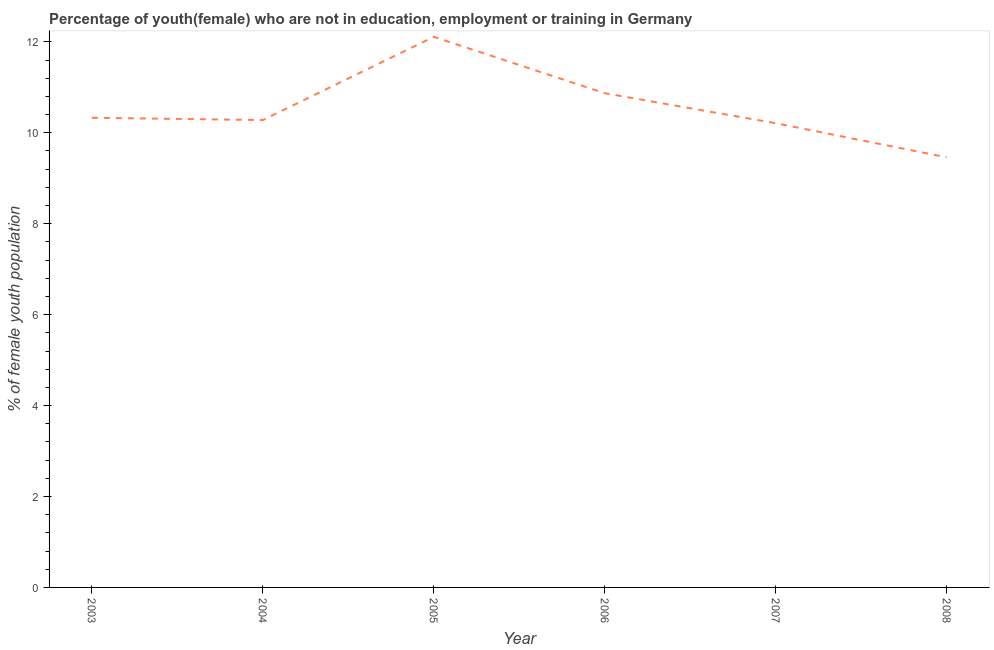What is the unemployed female youth population in 2004?
Your answer should be compact. 10.28. Across all years, what is the maximum unemployed female youth population?
Offer a very short reply. 12.11. Across all years, what is the minimum unemployed female youth population?
Provide a short and direct response. 9.46. What is the sum of the unemployed female youth population?
Your answer should be compact. 63.26. What is the difference between the unemployed female youth population in 2003 and 2008?
Keep it short and to the point. 0.87. What is the average unemployed female youth population per year?
Give a very brief answer. 10.54. What is the median unemployed female youth population?
Keep it short and to the point. 10.3. In how many years, is the unemployed female youth population greater than 3.2 %?
Provide a short and direct response. 6. Do a majority of the years between 2003 and 2008 (inclusive) have unemployed female youth population greater than 9.6 %?
Provide a short and direct response. Yes. What is the ratio of the unemployed female youth population in 2004 to that in 2006?
Offer a very short reply. 0.95. Is the unemployed female youth population in 2004 less than that in 2006?
Keep it short and to the point. Yes. Is the difference between the unemployed female youth population in 2006 and 2008 greater than the difference between any two years?
Give a very brief answer. No. What is the difference between the highest and the second highest unemployed female youth population?
Make the answer very short. 1.24. Is the sum of the unemployed female youth population in 2004 and 2008 greater than the maximum unemployed female youth population across all years?
Keep it short and to the point. Yes. What is the difference between the highest and the lowest unemployed female youth population?
Your response must be concise. 2.65. In how many years, is the unemployed female youth population greater than the average unemployed female youth population taken over all years?
Keep it short and to the point. 2. How many years are there in the graph?
Offer a terse response. 6. Does the graph contain any zero values?
Make the answer very short. No. What is the title of the graph?
Your response must be concise. Percentage of youth(female) who are not in education, employment or training in Germany. What is the label or title of the X-axis?
Keep it short and to the point. Year. What is the label or title of the Y-axis?
Your response must be concise. % of female youth population. What is the % of female youth population in 2003?
Your answer should be very brief. 10.33. What is the % of female youth population of 2004?
Keep it short and to the point. 10.28. What is the % of female youth population of 2005?
Offer a terse response. 12.11. What is the % of female youth population of 2006?
Provide a short and direct response. 10.87. What is the % of female youth population in 2007?
Your answer should be compact. 10.21. What is the % of female youth population in 2008?
Keep it short and to the point. 9.46. What is the difference between the % of female youth population in 2003 and 2005?
Keep it short and to the point. -1.78. What is the difference between the % of female youth population in 2003 and 2006?
Provide a succinct answer. -0.54. What is the difference between the % of female youth population in 2003 and 2007?
Keep it short and to the point. 0.12. What is the difference between the % of female youth population in 2003 and 2008?
Ensure brevity in your answer.  0.87. What is the difference between the % of female youth population in 2004 and 2005?
Your answer should be compact. -1.83. What is the difference between the % of female youth population in 2004 and 2006?
Give a very brief answer. -0.59. What is the difference between the % of female youth population in 2004 and 2007?
Give a very brief answer. 0.07. What is the difference between the % of female youth population in 2004 and 2008?
Keep it short and to the point. 0.82. What is the difference between the % of female youth population in 2005 and 2006?
Offer a terse response. 1.24. What is the difference between the % of female youth population in 2005 and 2007?
Provide a short and direct response. 1.9. What is the difference between the % of female youth population in 2005 and 2008?
Make the answer very short. 2.65. What is the difference between the % of female youth population in 2006 and 2007?
Your response must be concise. 0.66. What is the difference between the % of female youth population in 2006 and 2008?
Ensure brevity in your answer.  1.41. What is the ratio of the % of female youth population in 2003 to that in 2004?
Provide a short and direct response. 1. What is the ratio of the % of female youth population in 2003 to that in 2005?
Offer a very short reply. 0.85. What is the ratio of the % of female youth population in 2003 to that in 2006?
Ensure brevity in your answer.  0.95. What is the ratio of the % of female youth population in 2003 to that in 2008?
Your answer should be compact. 1.09. What is the ratio of the % of female youth population in 2004 to that in 2005?
Your response must be concise. 0.85. What is the ratio of the % of female youth population in 2004 to that in 2006?
Offer a very short reply. 0.95. What is the ratio of the % of female youth population in 2004 to that in 2007?
Provide a short and direct response. 1.01. What is the ratio of the % of female youth population in 2004 to that in 2008?
Keep it short and to the point. 1.09. What is the ratio of the % of female youth population in 2005 to that in 2006?
Offer a very short reply. 1.11. What is the ratio of the % of female youth population in 2005 to that in 2007?
Provide a short and direct response. 1.19. What is the ratio of the % of female youth population in 2005 to that in 2008?
Your answer should be compact. 1.28. What is the ratio of the % of female youth population in 2006 to that in 2007?
Provide a short and direct response. 1.06. What is the ratio of the % of female youth population in 2006 to that in 2008?
Ensure brevity in your answer.  1.15. What is the ratio of the % of female youth population in 2007 to that in 2008?
Provide a short and direct response. 1.08. 